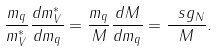<formula> <loc_0><loc_0><loc_500><loc_500>\frac { m _ { q } } { m _ { V } ^ { * } } \frac { d m ^ { * } _ { V } } { d m _ { q } } = \frac { m _ { q } } { M } \frac { d M } { d m _ { q } } = \frac { \ s g _ { N } } { M } .</formula> 